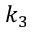Convert formula to latex. <formula><loc_0><loc_0><loc_500><loc_500>k _ { 3 }</formula> 